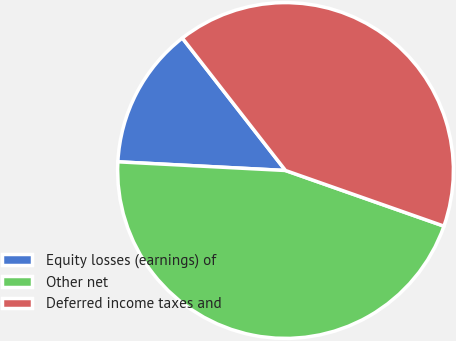Convert chart to OTSL. <chart><loc_0><loc_0><loc_500><loc_500><pie_chart><fcel>Equity losses (earnings) of<fcel>Other net<fcel>Deferred income taxes and<nl><fcel>13.64%<fcel>45.45%<fcel>40.91%<nl></chart> 